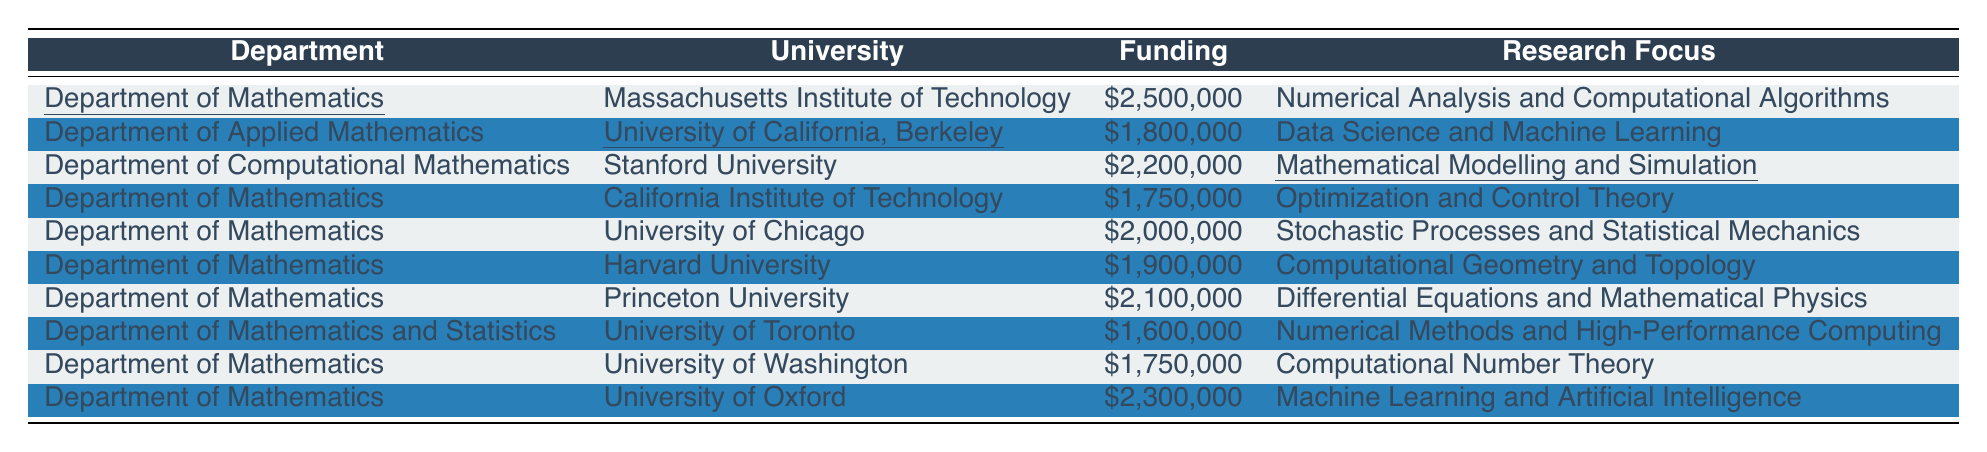What is the highest funding amount listed in the table? The highest funding amount is found by comparing all the funding values in the table. The amounts are: $2,500,000 (MIT), $1,800,000 (UC Berkeley), $2,200,000 (Stanford), $1,750,000 (Caltech), $2,000,000 (UChicago), $1,900,000 (Harvard), $2,100,000 (Princeton), $1,600,000 (Toronto), $1,750,000 (UWashington), and $2,300,000 (Oxford). The highest among these is $2,500,000.
Answer: $2,500,000 What is the average funding amount for the departments listed? To calculate the average, first sum the funding amounts: $2,500,000 + $1,800,000 + $2,200,000 + $1,750,000 + $2,000,000 + $1,900,000 + $2,100,000 + $1,600,000 + $1,750,000 + $2,300,000 = $21,100,000. There are 10 departments, thus the average is $21,100,000 / 10 = $2,110,000.
Answer: $2,110,000 Which department focuses on "Data Science and Machine Learning"? Referring directly to the table, the "Data Science and Machine Learning" focus is associated with the "Department of Applied Mathematics" at the University of California, Berkeley.
Answer: Department of Applied Mathematics Is there a department that received less than $1,600,000 in funding? Looking at all funding amounts listed, the lowest is $1,600,000 from the Department of Mathematics and Statistics at the University of Toronto. Since none are below this amount, the answer is no.
Answer: No Which university has the highest funding for its mathematics department? The universities with their corresponding mathematics funding amounts are: MIT - $2,500,000, UC Berkeley - $1,800,000, Stanford - $2,200,000, Caltech - $1,750,000, UChicago - $2,000,000, Harvard - $1,900,000, Princeton - $2,100,000, Toronto - $1,600,000, UWashington - $1,750,000, and Oxford - $2,300,000. The highest funding is from MIT, which is $2,500,000.
Answer: Massachusetts Institute of Technology What is the total funding for departments with a major focus on "Numerical Analysis" or "Numerical Methods"? From the table, the Department of Mathematics at MIT (Numerical Analysis) has $2,500,000, and the Department of Mathematics and Statistics at Toronto (Numerical Methods) has $1,600,000. Summing these gives $2,500,000 + $1,600,000 = $4,100,000.
Answer: $4,100,000 Are there more departments focusing on "Machine Learning" compared to "Numerical Analysis"? From the table, there are 2 departments with a major focus on "Machine Learning" (UC Berkeley and Oxford) and 1 on "Numerical Analysis" (MIT). Since 2 is greater than 1, the answer is yes.
Answer: Yes What is the funding difference between the department with the most and least funding? The highest funding amount is $2,500,000 from MIT and the lowest is $1,600,000 from Toronto. The difference is calculated as $2,500,000 - $1,600,000 = $900,000.
Answer: $900,000 Which department has a research focus on "Computational Geometry and Topology"? Referring to the table, "Computational Geometry and Topology" is listed under the Department of Mathematics at Harvard University.
Answer: Department of Mathematics at Harvard University How many departments received funding between $1,800,000 and $2,200,000? The amounts within this range are: $1,800,000 (UC Berkeley), $2,000,000 (UChicago), and $2,100,000 (Princeton). Counting these gives 3 departments.
Answer: 3 